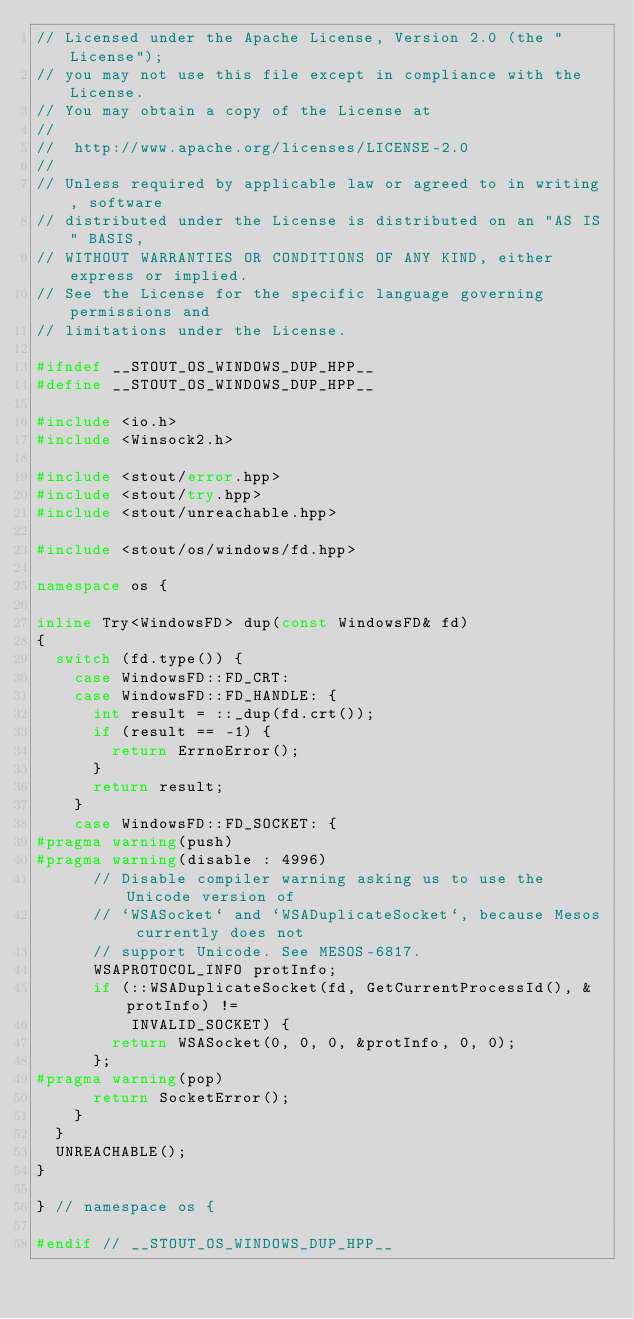Convert code to text. <code><loc_0><loc_0><loc_500><loc_500><_C++_>// Licensed under the Apache License, Version 2.0 (the "License");
// you may not use this file except in compliance with the License.
// You may obtain a copy of the License at
//
//  http://www.apache.org/licenses/LICENSE-2.0
//
// Unless required by applicable law or agreed to in writing, software
// distributed under the License is distributed on an "AS IS" BASIS,
// WITHOUT WARRANTIES OR CONDITIONS OF ANY KIND, either express or implied.
// See the License for the specific language governing permissions and
// limitations under the License.

#ifndef __STOUT_OS_WINDOWS_DUP_HPP__
#define __STOUT_OS_WINDOWS_DUP_HPP__

#include <io.h>
#include <Winsock2.h>

#include <stout/error.hpp>
#include <stout/try.hpp>
#include <stout/unreachable.hpp>

#include <stout/os/windows/fd.hpp>

namespace os {

inline Try<WindowsFD> dup(const WindowsFD& fd)
{
  switch (fd.type()) {
    case WindowsFD::FD_CRT:
    case WindowsFD::FD_HANDLE: {
      int result = ::_dup(fd.crt());
      if (result == -1) {
        return ErrnoError();
      }
      return result;
    }
    case WindowsFD::FD_SOCKET: {
#pragma warning(push)
#pragma warning(disable : 4996)
      // Disable compiler warning asking us to use the Unicode version of
      // `WSASocket` and `WSADuplicateSocket`, because Mesos currently does not
      // support Unicode. See MESOS-6817.
      WSAPROTOCOL_INFO protInfo;
      if (::WSADuplicateSocket(fd, GetCurrentProcessId(), &protInfo) !=
          INVALID_SOCKET) {
        return WSASocket(0, 0, 0, &protInfo, 0, 0);
      };
#pragma warning(pop)
      return SocketError();
    }
  }
  UNREACHABLE();
}

} // namespace os {

#endif // __STOUT_OS_WINDOWS_DUP_HPP__
</code> 